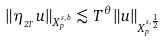Convert formula to latex. <formula><loc_0><loc_0><loc_500><loc_500>\| \eta _ { _ { 2 T } } u \| _ { X ^ { s , b } _ { p } } \lesssim T ^ { \theta } \| u \| _ { X ^ { s , \frac { 1 } { 2 } } _ { p } }</formula> 